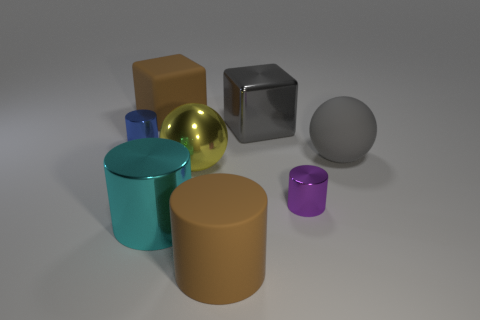Subtract all tiny purple metal cylinders. How many cylinders are left? 3 Add 1 yellow balls. How many objects exist? 9 Subtract all brown cylinders. How many cylinders are left? 3 Subtract all big gray balls. Subtract all cylinders. How many objects are left? 3 Add 6 big brown rubber cubes. How many big brown rubber cubes are left? 7 Add 7 tiny yellow cylinders. How many tiny yellow cylinders exist? 7 Subtract 0 gray cylinders. How many objects are left? 8 Subtract all cubes. How many objects are left? 6 Subtract 1 cylinders. How many cylinders are left? 3 Subtract all purple cubes. Subtract all gray cylinders. How many cubes are left? 2 